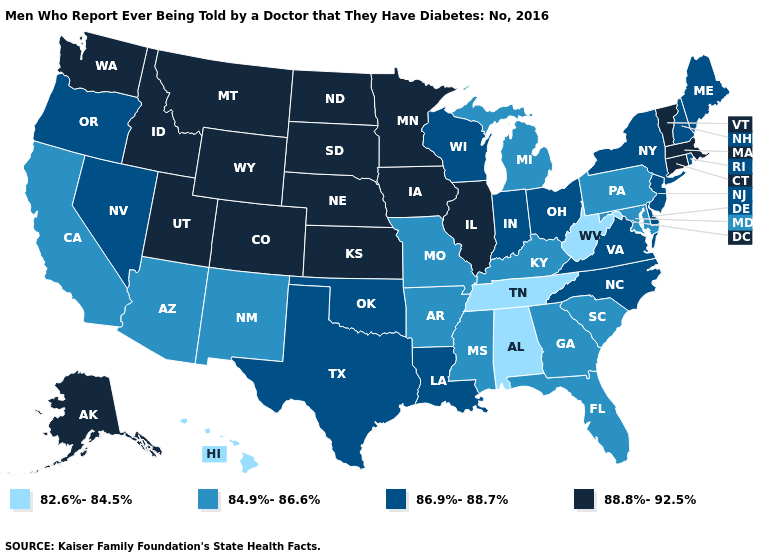Does Vermont have the lowest value in the USA?
Be succinct. No. Does the map have missing data?
Concise answer only. No. What is the lowest value in the USA?
Concise answer only. 82.6%-84.5%. Does Missouri have the lowest value in the MidWest?
Keep it brief. Yes. What is the lowest value in the South?
Be succinct. 82.6%-84.5%. Which states have the lowest value in the USA?
Keep it brief. Alabama, Hawaii, Tennessee, West Virginia. Name the states that have a value in the range 88.8%-92.5%?
Write a very short answer. Alaska, Colorado, Connecticut, Idaho, Illinois, Iowa, Kansas, Massachusetts, Minnesota, Montana, Nebraska, North Dakota, South Dakota, Utah, Vermont, Washington, Wyoming. Name the states that have a value in the range 86.9%-88.7%?
Write a very short answer. Delaware, Indiana, Louisiana, Maine, Nevada, New Hampshire, New Jersey, New York, North Carolina, Ohio, Oklahoma, Oregon, Rhode Island, Texas, Virginia, Wisconsin. What is the value of Illinois?
Quick response, please. 88.8%-92.5%. What is the lowest value in the USA?
Write a very short answer. 82.6%-84.5%. Name the states that have a value in the range 86.9%-88.7%?
Concise answer only. Delaware, Indiana, Louisiana, Maine, Nevada, New Hampshire, New Jersey, New York, North Carolina, Ohio, Oklahoma, Oregon, Rhode Island, Texas, Virginia, Wisconsin. What is the value of Colorado?
Keep it brief. 88.8%-92.5%. Does Idaho have the highest value in the USA?
Give a very brief answer. Yes. Which states hav the highest value in the South?
Keep it brief. Delaware, Louisiana, North Carolina, Oklahoma, Texas, Virginia. 